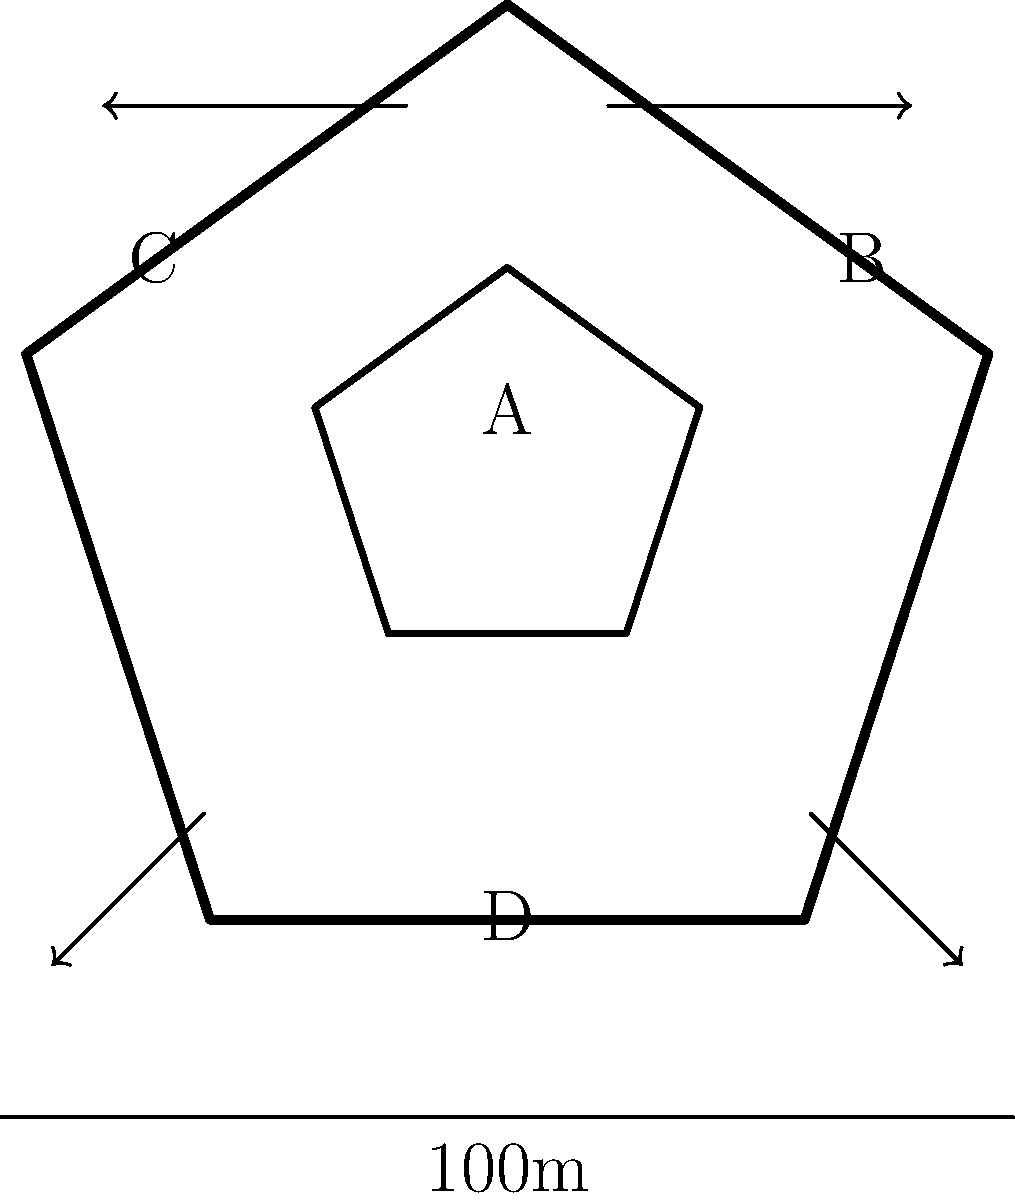In the diagram of a traditional Japanese castle layout, which area would be most suitable for placing archers to defend against incoming attacks, considering the castle's defensive features? To determine the best location for archers in this Japanese castle layout, we need to consider several factors:

1. Elevation: Archers are most effective when positioned at higher points, providing a better vantage point and range.
2. Field of view: The chosen location should offer a wide field of view to cover multiple approach angles.
3. Protection: Archers need some level of protection while maintaining their ability to shoot effectively.
4. Strategic importance: The location should be crucial for the overall defense of the castle.

Analyzing the given areas:

A: This appears to be the inner keep (tenshu). While it offers height, it's typically reserved for the lord and important officials, not for a large number of archers.

B and C: These areas are on the outer walls of the castle, offering a good field of view and strategic positioning for defending against frontal attacks.

D: This area is at the base of the castle, which wouldn't provide the necessary elevation for effective archery.

Considering these factors, areas B and C on the outer walls would be the most suitable locations for placing archers. They provide:

1. Elevated positions compared to the surrounding area.
2. Wide fields of view to cover multiple approach angles.
3. The castle walls offer some protection while allowing archers to shoot over them.
4. Strategic positioning to defend against frontal attacks and cover the main approaches to the castle.

Therefore, the best answer would be a combination of areas B and C.
Answer: B and C 